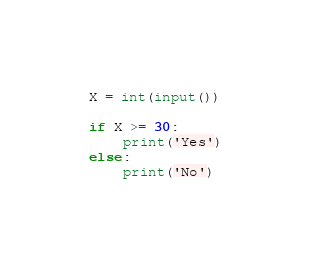<code> <loc_0><loc_0><loc_500><loc_500><_Python_>X = int(input())

if X >= 30:
    print('Yes')
else:
    print('No')</code> 